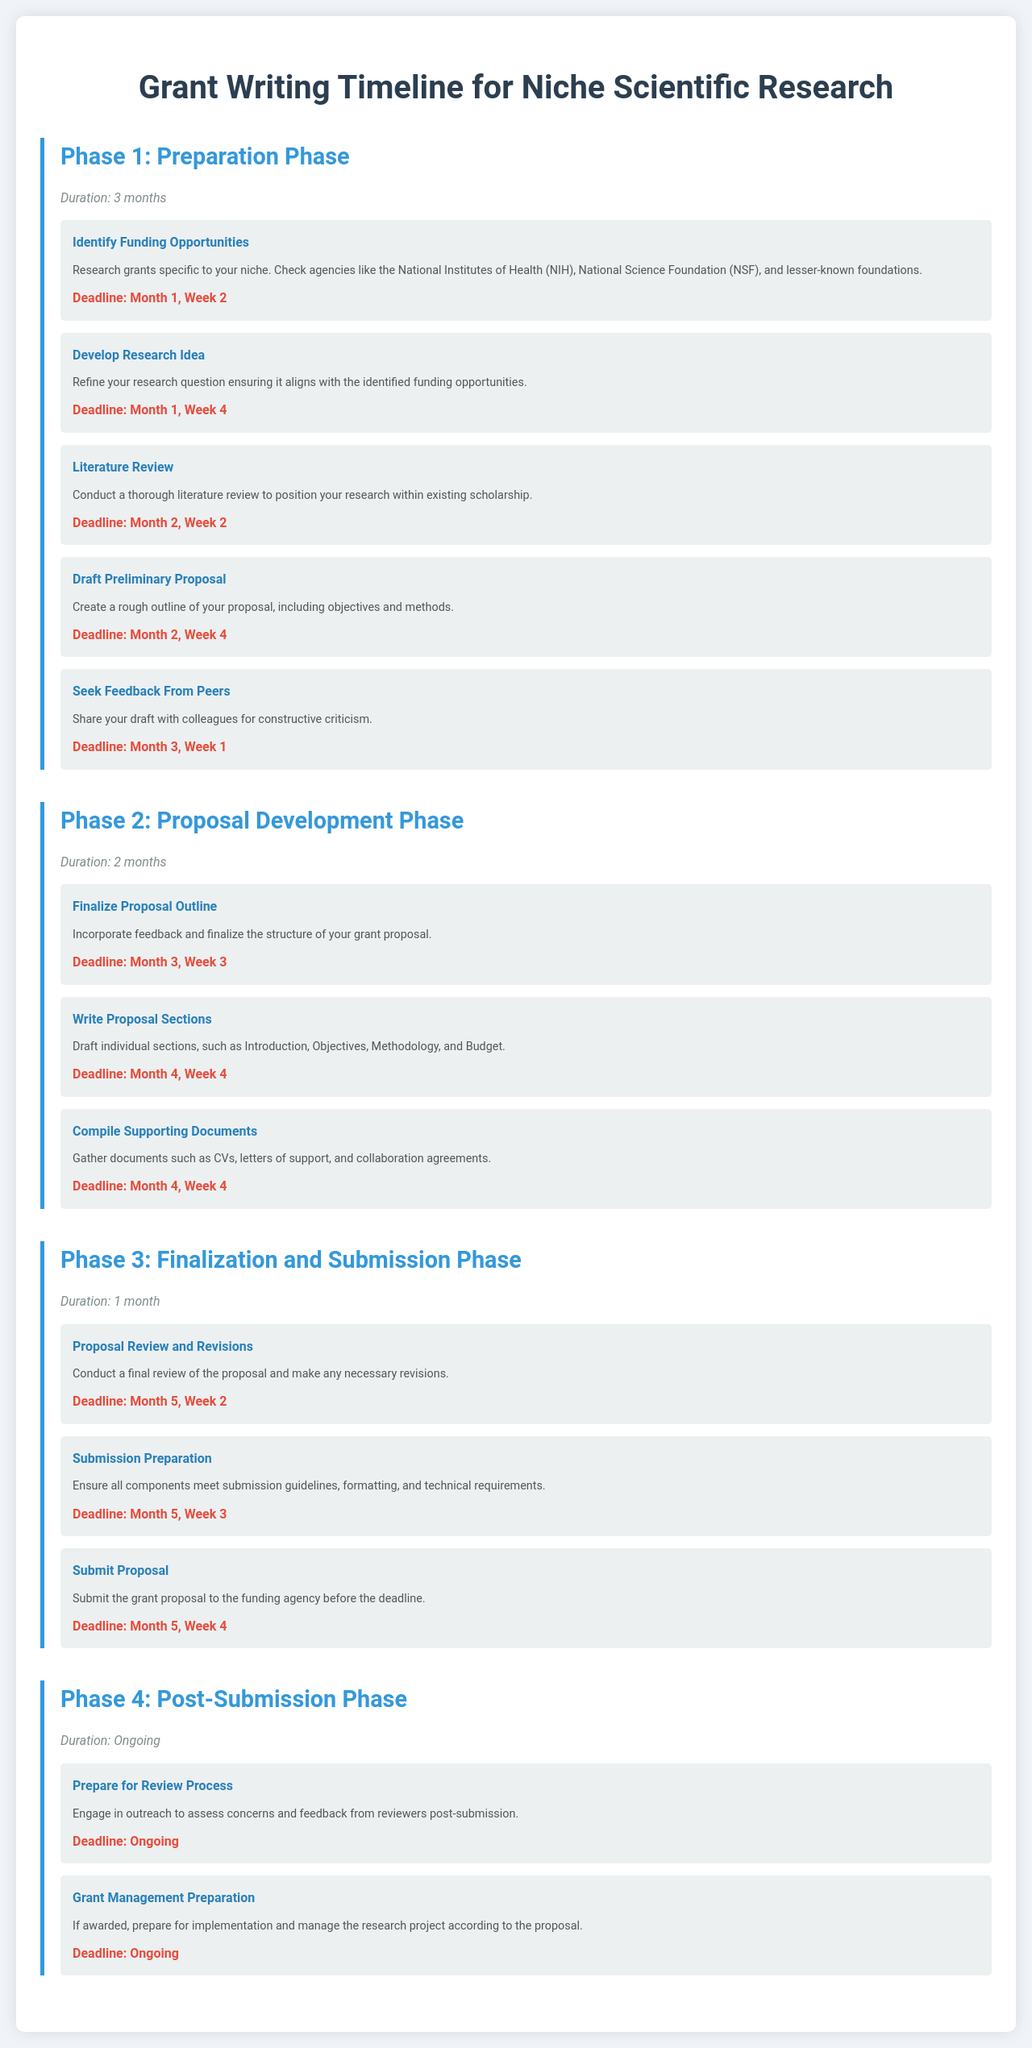what is the duration of Phase 1? The duration of Phase 1 is mentioned as “3 months” in the document.
Answer: 3 months what milestone is due in Month 3, Week 3? The document lists the milestone titled “Finalize Proposal Outline” as due in Month 3, Week 3.
Answer: Finalize Proposal Outline how many phases are there in total in the document? The document outlines four distinct phases in total.
Answer: 4 what is the deadline for submitting the proposal? The deadline for submitting the proposal is specified as “Month 5, Week 4.”
Answer: Month 5, Week 4 which agency is mentioned as a funding source in the preparation phase? The National Institutes of Health (NIH) is explicitly mentioned as a funding source in the preparation phase.
Answer: National Institutes of Health (NIH) what is the focus of the final milestone in Phase 3? The final milestone in Phase 3 is related to the submission of the grant proposal.
Answer: Submit Proposal during which phase should you conduct a literature review? The document indicates that the literature review is to be conducted during Phase 1.
Answer: Phase 1 what is the duration of the post-submission phase? The document states that the duration of the post-submission phase is ongoing.
Answer: Ongoing what type of feedback is sought in Month 3, Week 1? The feedback sought in Month 3, Week 1 is from peers for constructive criticism.
Answer: Peers 